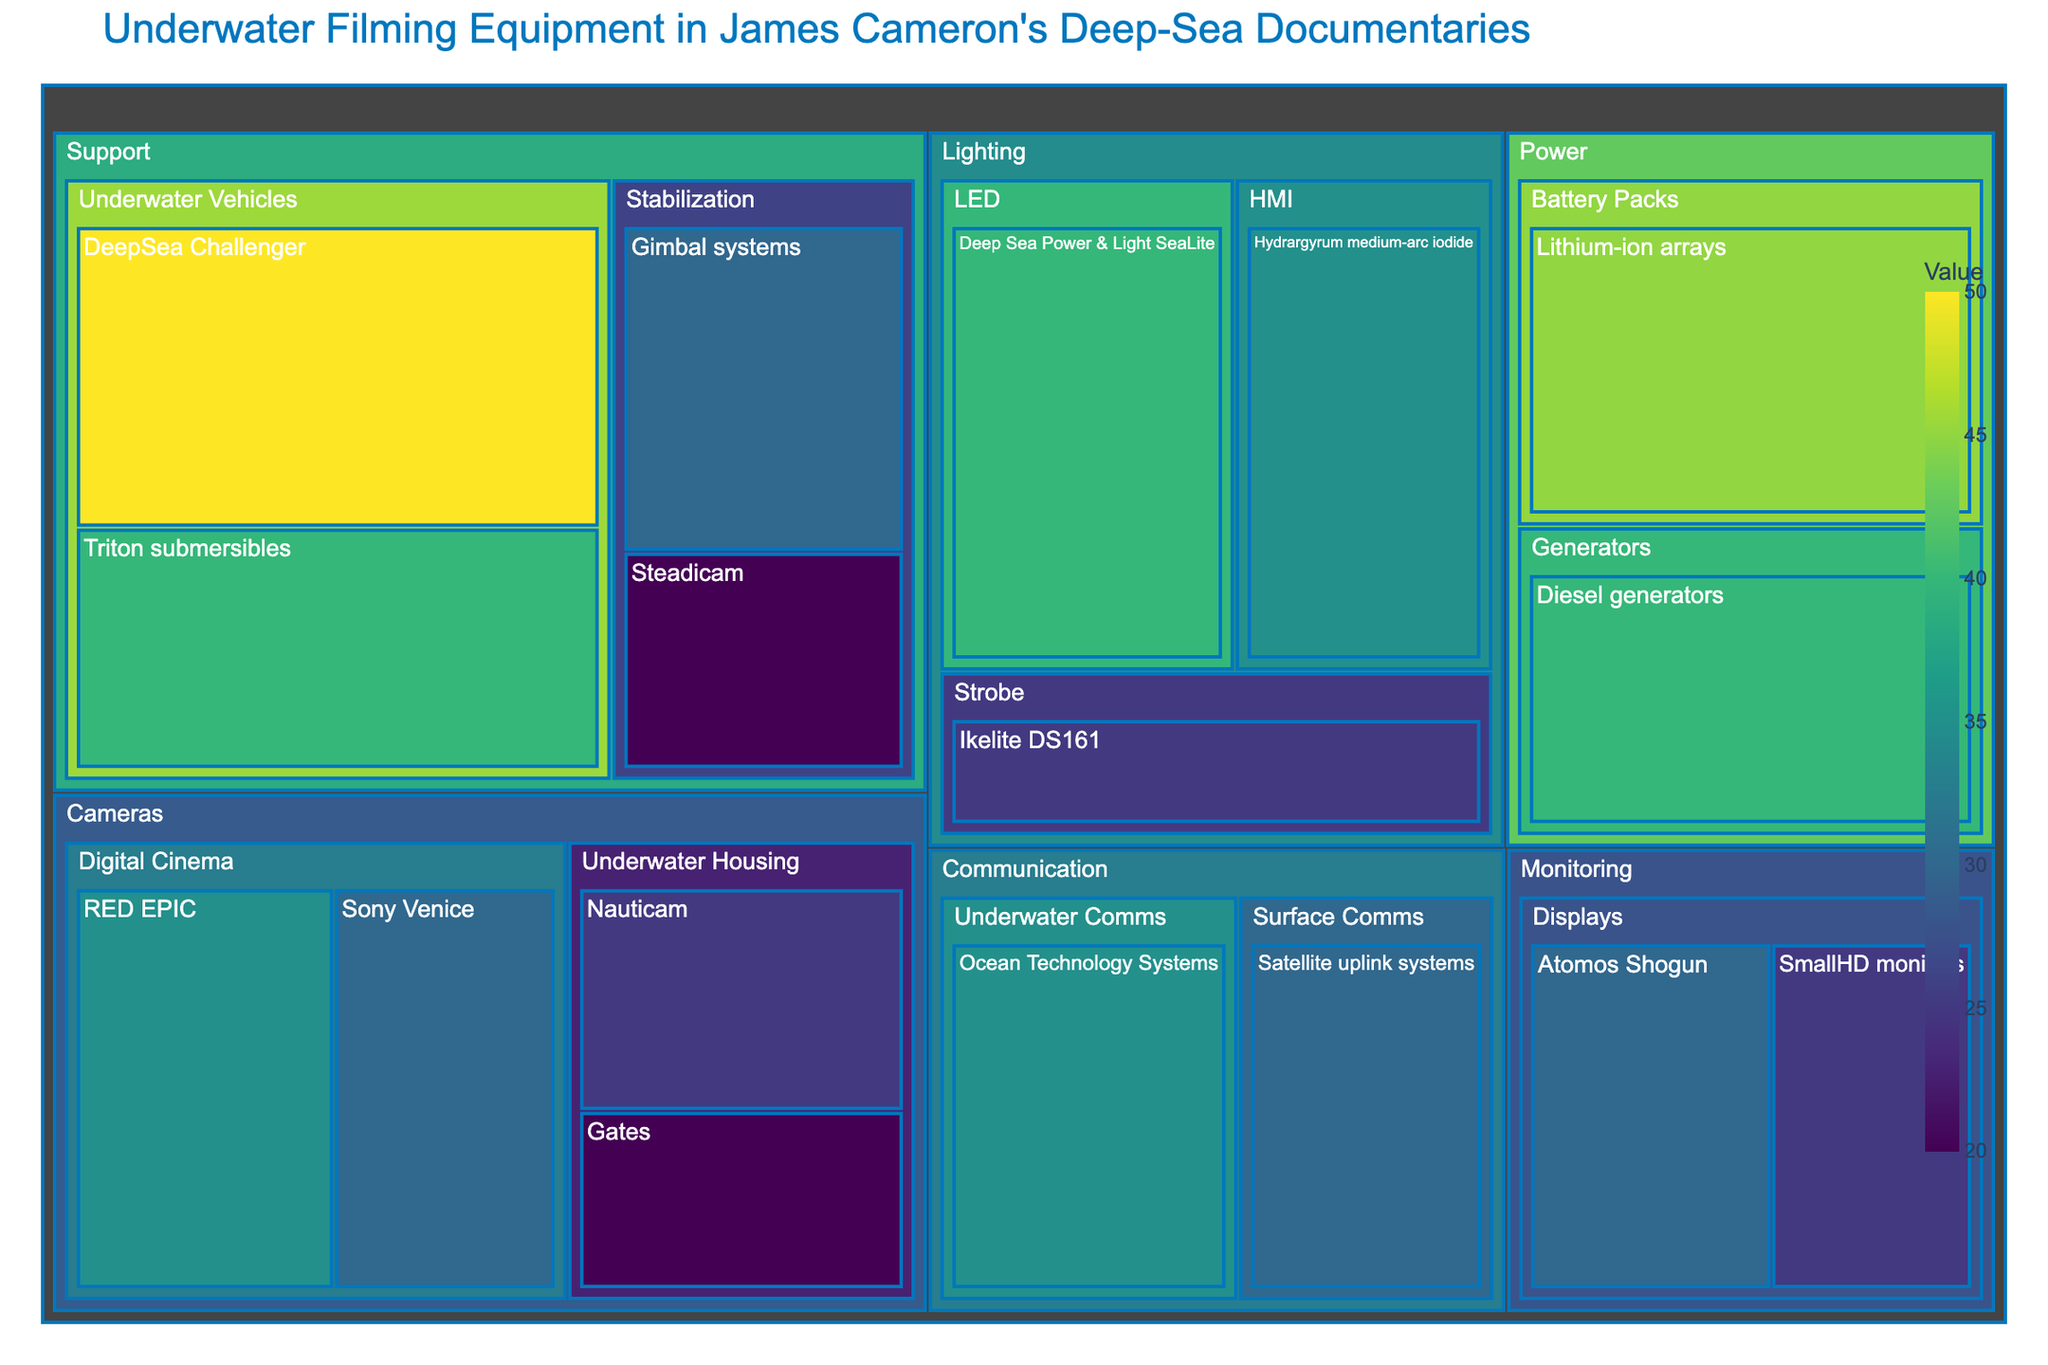What's the most prominent equipment category in the treemap? The treemap shows that the category with the highest value, which takes up the most space, is "Support" due to the high values (DeepSea Challenger: 50 and Triton submersibles: 40) under this category.
Answer: Support Which lighting equipment has the highest value in the treemap? In the "Lighting" category, the equipment "Deep Sea Power & Light SeaLite" from the LED subcategory has the highest value.
Answer: Deep Sea Power & Light SeaLite What is the combined value of the items in the "Cameras" category? The "Cameras" category contains four items: RED EPIC (35), Sony Venice (30), Nauticam (25), and Gates (20). Summing these values gives 35 + 30 + 25 + 20 = 110.
Answer: 110 Which equipment within the "Power" category has a higher value: lithium-ion arrays or diesel generators? In the "Power" category, lithium-ion arrays have a value of 45, and diesel generators have a value of 40. Therefore, lithium-ion arrays have a higher value.
Answer: Lithium-ion arrays Compare the values of "Steadicam" and "Gimbal systems" within the "Support" category. Which one is higher? Under the "Support" category, "Gimbal systems" has a value of 30, while "Steadicam" has a value of 20. Hence, "Gimbal systems" has a higher value.
Answer: Gimbal systems What is the aggregate value of the "Communication" category? The "Communication" category includes two items: Ocean Technology Systems (35) and Satellite uplink systems (30). Adding these values gives 35 + 30 = 65.
Answer: 65 Within the "Monitoring" category, which display equipment has a lower value? In the "Monitoring" category, Atomos Shogun has a value of 30, and SmallHD monitors have a value of 25. Therefore, SmallHD monitors have a lower value.
Answer: SmallHD monitors What is the smallest value represented in the entire treemap? The smallest value in the treemap is represented by "Steadicam" in the "Support" category, which has a value of 20.
Answer: 20 How do the values of "Strobe" lighting compare to "HMI" lighting? In the "Lighting" category, "Strobe" (Ikelite DS161) has a value of 25, and "HMI" (Hydrargyrum medium-arc iodide) has a value of 35. Therefore, "HMI" has a higher value compared to "Strobe".
Answer: HMI 